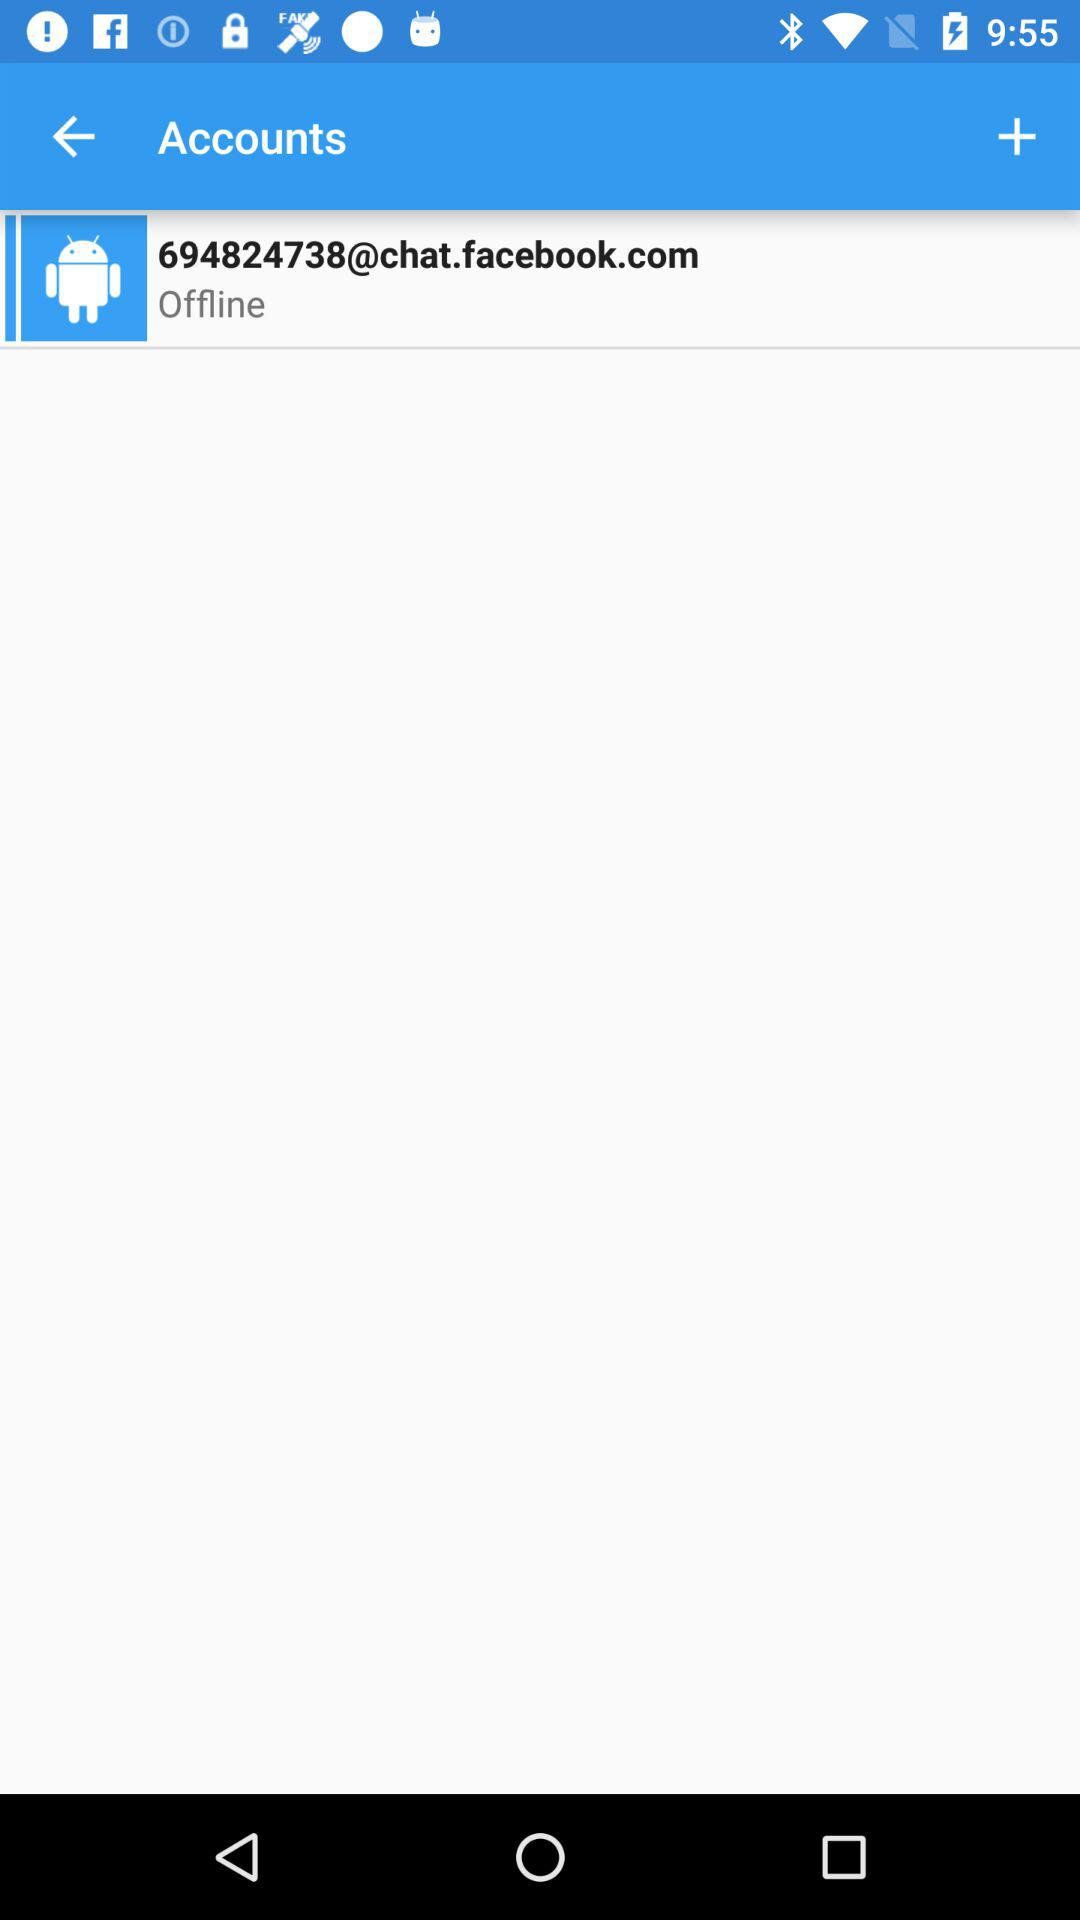Is the account online or offline? The account is offline. 